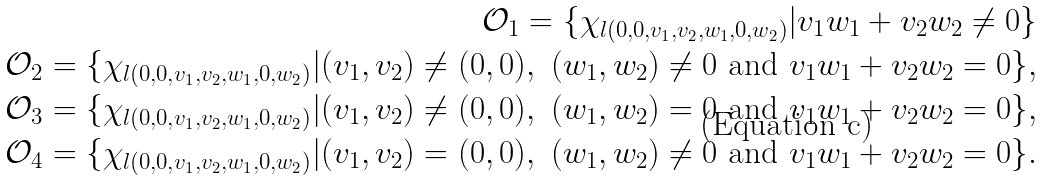<formula> <loc_0><loc_0><loc_500><loc_500>\mathcal { O } _ { 1 } = \{ \chi _ { l ( 0 , 0 , v _ { 1 } , v _ { 2 } , w _ { 1 } , 0 , w _ { 2 } ) } | v _ { 1 } w _ { 1 } + v _ { 2 } w _ { 2 } \neq 0 \} \\ \mathcal { O } _ { 2 } = \{ \chi _ { l ( 0 , 0 , v _ { 1 } , v _ { 2 } , w _ { 1 } , 0 , w _ { 2 } ) } | ( v _ { 1 } , v _ { 2 } ) \neq ( 0 , 0 ) , \ ( w _ { 1 } , w _ { 2 } ) \neq 0 \ \text {and} \ v _ { 1 } w _ { 1 } + v _ { 2 } w _ { 2 } = 0 \} , \\ \mathcal { O } _ { 3 } = \{ \chi _ { l ( 0 , 0 , v _ { 1 } , v _ { 2 } , w _ { 1 } , 0 , w _ { 2 } ) } | ( v _ { 1 } , v _ { 2 } ) \neq ( 0 , 0 ) , \ ( w _ { 1 } , w _ { 2 } ) = 0 \ \text {and} \ v _ { 1 } w _ { 1 } + v _ { 2 } w _ { 2 } = 0 \} , \\ \mathcal { O } _ { 4 } = \{ \chi _ { l ( 0 , 0 , v _ { 1 } , v _ { 2 } , w _ { 1 } , 0 , w _ { 2 } ) } | ( v _ { 1 } , v _ { 2 } ) = ( 0 , 0 ) , \ ( w _ { 1 } , w _ { 2 } ) \neq 0 \ \text {and} \ v _ { 1 } w _ { 1 } + v _ { 2 } w _ { 2 } = 0 \} .</formula> 